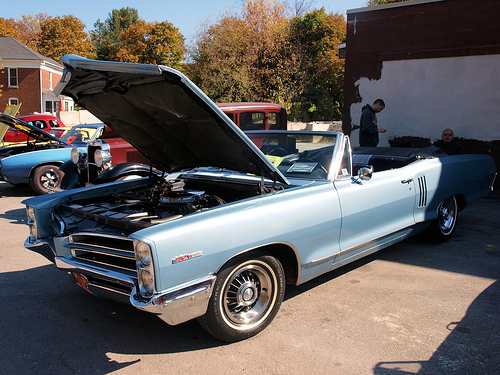<image>
Can you confirm if the car is behind the hood? Yes. From this viewpoint, the car is positioned behind the hood, with the hood partially or fully occluding the car. 